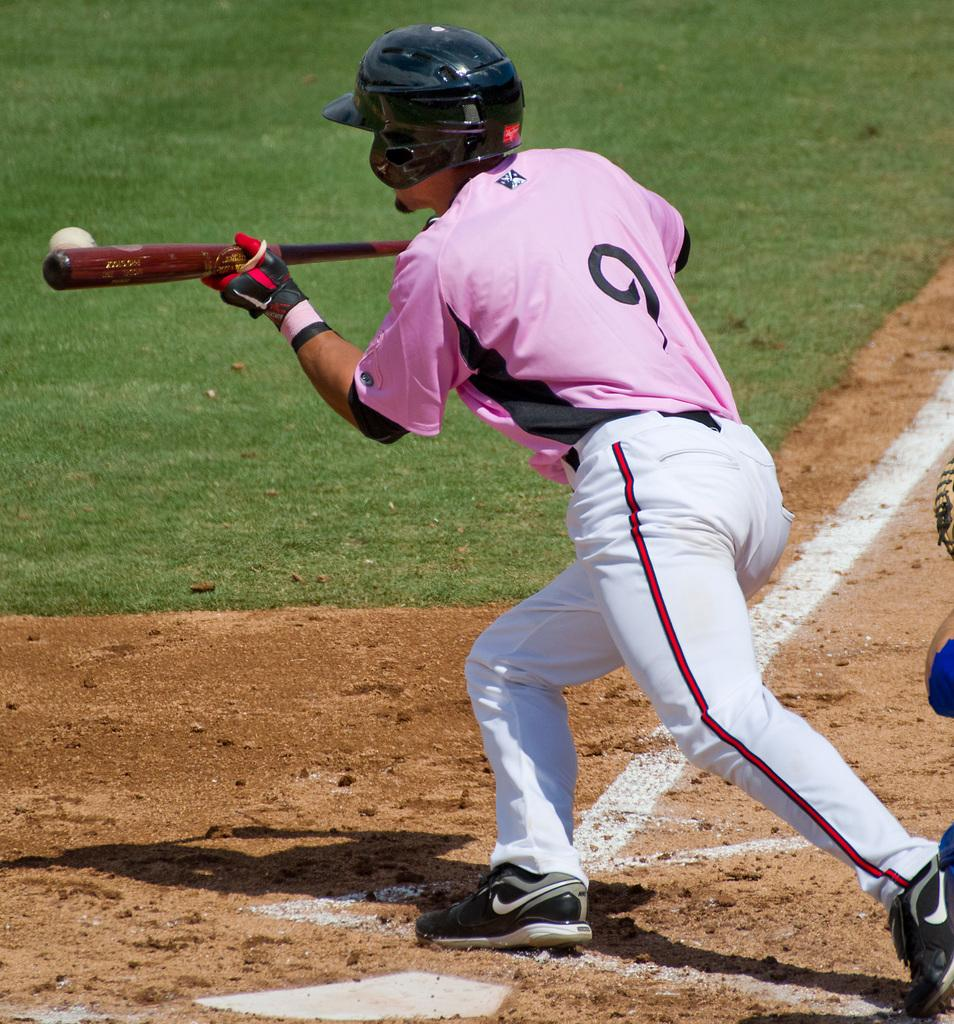What is the person in the image doing? The person is playing baseball. What color is the person's t-shirt? The person is wearing a pink t-shirt. What color are the person's trousers? The person is wearing white trousers. What type of protective gear is the person wearing? The person is wearing a black helmet. What type of cave can be seen in the background of the image? There is no cave present in the image; it features a person playing baseball. What does the person's tongue look like while playing baseball? The person's tongue is not visible in the image, so it cannot be described. 